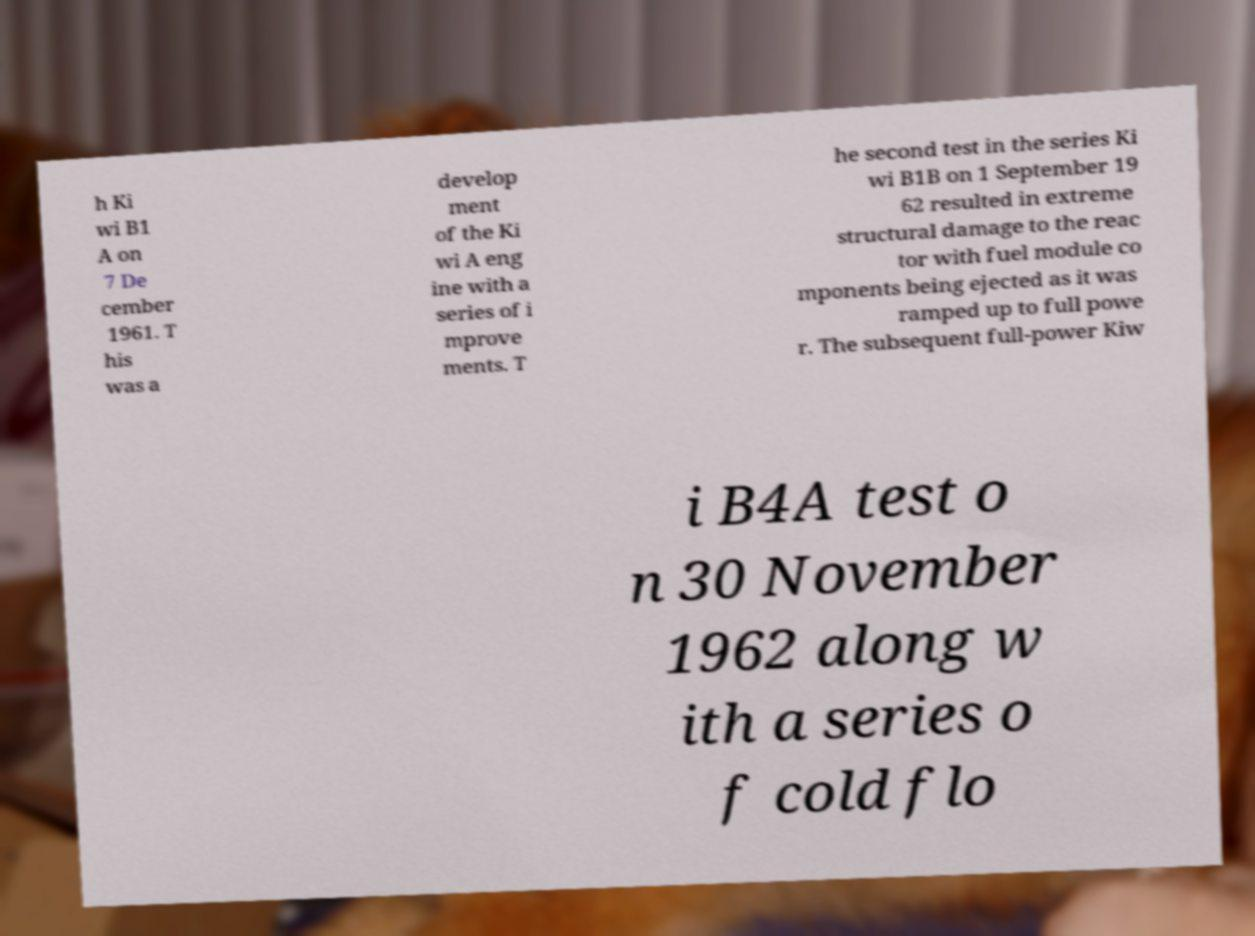Can you accurately transcribe the text from the provided image for me? h Ki wi B1 A on 7 De cember 1961. T his was a develop ment of the Ki wi A eng ine with a series of i mprove ments. T he second test in the series Ki wi B1B on 1 September 19 62 resulted in extreme structural damage to the reac tor with fuel module co mponents being ejected as it was ramped up to full powe r. The subsequent full-power Kiw i B4A test o n 30 November 1962 along w ith a series o f cold flo 